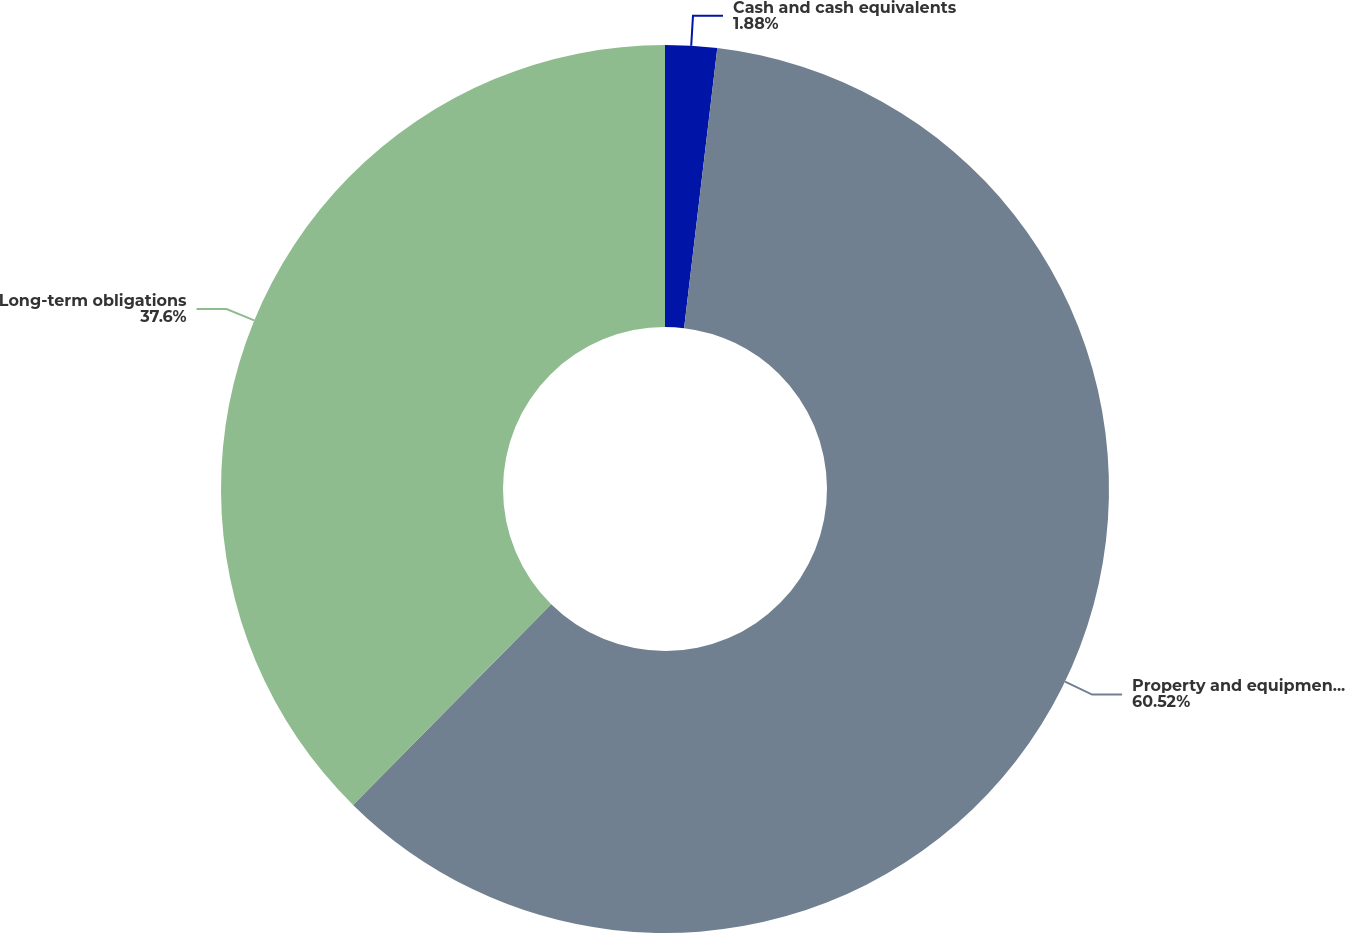<chart> <loc_0><loc_0><loc_500><loc_500><pie_chart><fcel>Cash and cash equivalents<fcel>Property and equipment net<fcel>Long-term obligations<nl><fcel>1.88%<fcel>60.52%<fcel>37.6%<nl></chart> 